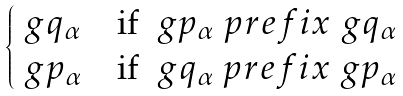<formula> <loc_0><loc_0><loc_500><loc_500>\begin{cases} \ g q _ { \alpha } & \text {if } \ g p _ { \alpha } \ p r e f i x \ g q _ { \alpha } \\ \ g p _ { \alpha } & \text {if } \ g q _ { \alpha } \ p r e f i x \ g p _ { \alpha } \end{cases}</formula> 